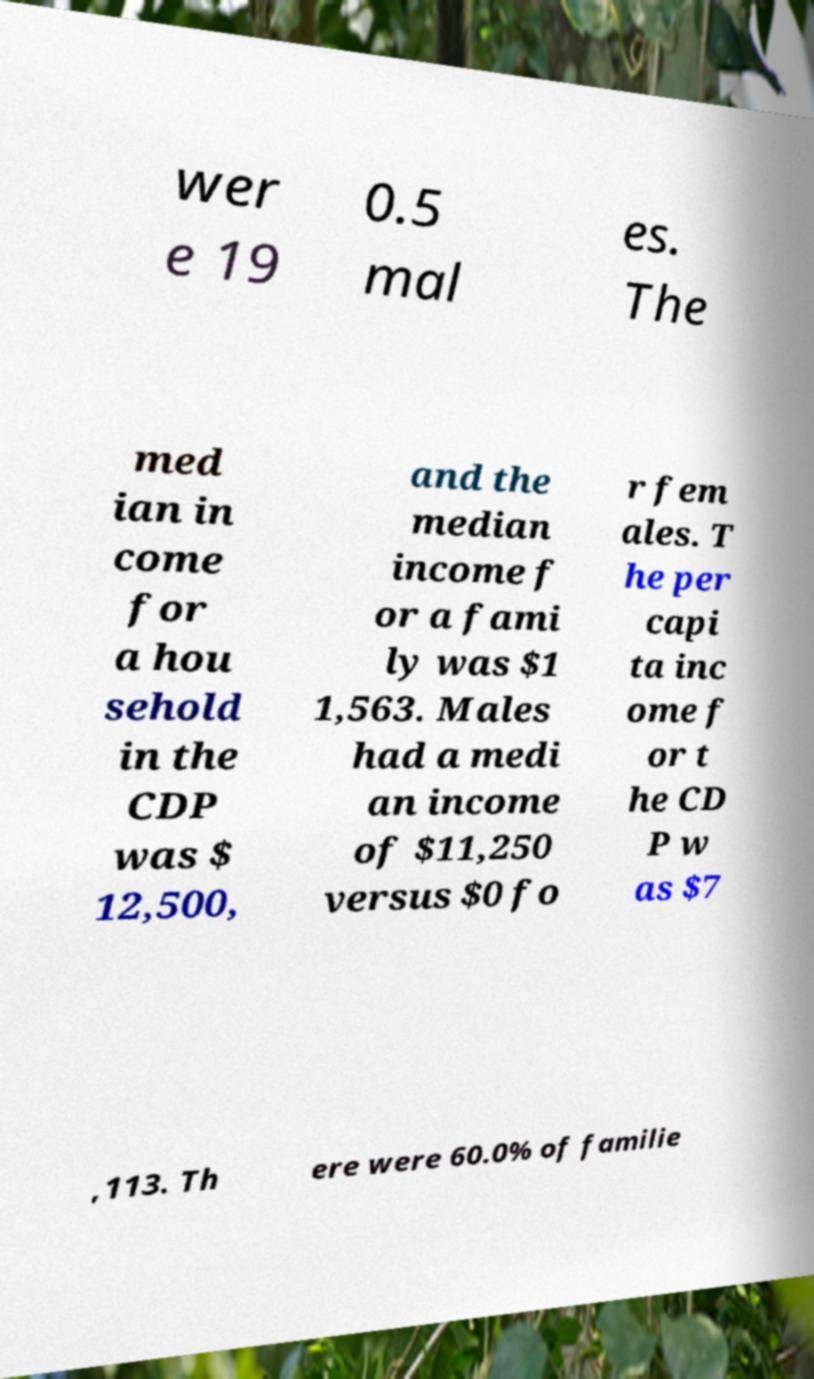Could you assist in decoding the text presented in this image and type it out clearly? wer e 19 0.5 mal es. The med ian in come for a hou sehold in the CDP was $ 12,500, and the median income f or a fami ly was $1 1,563. Males had a medi an income of $11,250 versus $0 fo r fem ales. T he per capi ta inc ome f or t he CD P w as $7 ,113. Th ere were 60.0% of familie 